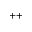<formula> <loc_0><loc_0><loc_500><loc_500>^ { + + }</formula> 